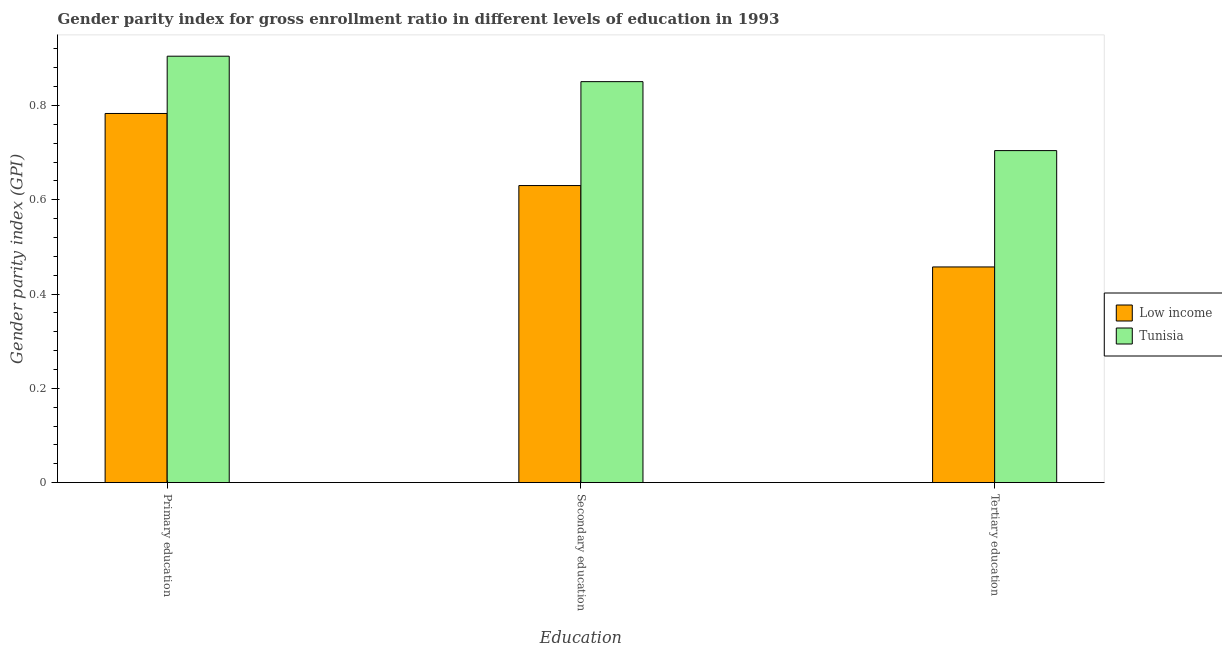How many different coloured bars are there?
Your response must be concise. 2. How many groups of bars are there?
Offer a terse response. 3. Are the number of bars per tick equal to the number of legend labels?
Provide a short and direct response. Yes. How many bars are there on the 3rd tick from the right?
Offer a terse response. 2. What is the label of the 2nd group of bars from the left?
Offer a terse response. Secondary education. What is the gender parity index in tertiary education in Low income?
Make the answer very short. 0.46. Across all countries, what is the maximum gender parity index in secondary education?
Provide a succinct answer. 0.85. Across all countries, what is the minimum gender parity index in primary education?
Your answer should be compact. 0.78. In which country was the gender parity index in secondary education maximum?
Offer a terse response. Tunisia. In which country was the gender parity index in secondary education minimum?
Provide a succinct answer. Low income. What is the total gender parity index in tertiary education in the graph?
Your answer should be compact. 1.16. What is the difference between the gender parity index in primary education in Low income and that in Tunisia?
Offer a very short reply. -0.12. What is the difference between the gender parity index in primary education in Low income and the gender parity index in tertiary education in Tunisia?
Your answer should be very brief. 0.08. What is the average gender parity index in primary education per country?
Your answer should be compact. 0.84. What is the difference between the gender parity index in secondary education and gender parity index in tertiary education in Low income?
Give a very brief answer. 0.17. What is the ratio of the gender parity index in tertiary education in Tunisia to that in Low income?
Your response must be concise. 1.54. Is the gender parity index in secondary education in Low income less than that in Tunisia?
Your response must be concise. Yes. Is the difference between the gender parity index in tertiary education in Tunisia and Low income greater than the difference between the gender parity index in secondary education in Tunisia and Low income?
Make the answer very short. Yes. What is the difference between the highest and the second highest gender parity index in tertiary education?
Offer a very short reply. 0.25. What is the difference between the highest and the lowest gender parity index in primary education?
Give a very brief answer. 0.12. In how many countries, is the gender parity index in tertiary education greater than the average gender parity index in tertiary education taken over all countries?
Your response must be concise. 1. What does the 2nd bar from the left in Secondary education represents?
Give a very brief answer. Tunisia. What does the 1st bar from the right in Tertiary education represents?
Your answer should be very brief. Tunisia. What is the difference between two consecutive major ticks on the Y-axis?
Ensure brevity in your answer.  0.2. Are the values on the major ticks of Y-axis written in scientific E-notation?
Ensure brevity in your answer.  No. What is the title of the graph?
Give a very brief answer. Gender parity index for gross enrollment ratio in different levels of education in 1993. What is the label or title of the X-axis?
Provide a short and direct response. Education. What is the label or title of the Y-axis?
Offer a terse response. Gender parity index (GPI). What is the Gender parity index (GPI) of Low income in Primary education?
Provide a short and direct response. 0.78. What is the Gender parity index (GPI) of Tunisia in Primary education?
Provide a short and direct response. 0.9. What is the Gender parity index (GPI) of Low income in Secondary education?
Your answer should be very brief. 0.63. What is the Gender parity index (GPI) of Tunisia in Secondary education?
Provide a short and direct response. 0.85. What is the Gender parity index (GPI) of Low income in Tertiary education?
Ensure brevity in your answer.  0.46. What is the Gender parity index (GPI) of Tunisia in Tertiary education?
Provide a succinct answer. 0.7. Across all Education, what is the maximum Gender parity index (GPI) of Low income?
Your answer should be very brief. 0.78. Across all Education, what is the maximum Gender parity index (GPI) of Tunisia?
Offer a very short reply. 0.9. Across all Education, what is the minimum Gender parity index (GPI) of Low income?
Your answer should be very brief. 0.46. Across all Education, what is the minimum Gender parity index (GPI) in Tunisia?
Keep it short and to the point. 0.7. What is the total Gender parity index (GPI) in Low income in the graph?
Your answer should be very brief. 1.87. What is the total Gender parity index (GPI) of Tunisia in the graph?
Provide a succinct answer. 2.46. What is the difference between the Gender parity index (GPI) of Low income in Primary education and that in Secondary education?
Your response must be concise. 0.15. What is the difference between the Gender parity index (GPI) in Tunisia in Primary education and that in Secondary education?
Your answer should be very brief. 0.05. What is the difference between the Gender parity index (GPI) of Low income in Primary education and that in Tertiary education?
Offer a terse response. 0.33. What is the difference between the Gender parity index (GPI) of Tunisia in Primary education and that in Tertiary education?
Give a very brief answer. 0.2. What is the difference between the Gender parity index (GPI) in Low income in Secondary education and that in Tertiary education?
Your response must be concise. 0.17. What is the difference between the Gender parity index (GPI) of Tunisia in Secondary education and that in Tertiary education?
Your response must be concise. 0.15. What is the difference between the Gender parity index (GPI) of Low income in Primary education and the Gender parity index (GPI) of Tunisia in Secondary education?
Offer a very short reply. -0.07. What is the difference between the Gender parity index (GPI) in Low income in Primary education and the Gender parity index (GPI) in Tunisia in Tertiary education?
Your answer should be very brief. 0.08. What is the difference between the Gender parity index (GPI) in Low income in Secondary education and the Gender parity index (GPI) in Tunisia in Tertiary education?
Provide a succinct answer. -0.07. What is the average Gender parity index (GPI) in Low income per Education?
Your response must be concise. 0.62. What is the average Gender parity index (GPI) in Tunisia per Education?
Offer a terse response. 0.82. What is the difference between the Gender parity index (GPI) of Low income and Gender parity index (GPI) of Tunisia in Primary education?
Your response must be concise. -0.12. What is the difference between the Gender parity index (GPI) of Low income and Gender parity index (GPI) of Tunisia in Secondary education?
Provide a short and direct response. -0.22. What is the difference between the Gender parity index (GPI) in Low income and Gender parity index (GPI) in Tunisia in Tertiary education?
Give a very brief answer. -0.25. What is the ratio of the Gender parity index (GPI) of Low income in Primary education to that in Secondary education?
Keep it short and to the point. 1.24. What is the ratio of the Gender parity index (GPI) in Tunisia in Primary education to that in Secondary education?
Give a very brief answer. 1.06. What is the ratio of the Gender parity index (GPI) of Low income in Primary education to that in Tertiary education?
Offer a very short reply. 1.71. What is the ratio of the Gender parity index (GPI) in Tunisia in Primary education to that in Tertiary education?
Your response must be concise. 1.28. What is the ratio of the Gender parity index (GPI) in Low income in Secondary education to that in Tertiary education?
Your answer should be very brief. 1.38. What is the ratio of the Gender parity index (GPI) in Tunisia in Secondary education to that in Tertiary education?
Ensure brevity in your answer.  1.21. What is the difference between the highest and the second highest Gender parity index (GPI) in Low income?
Provide a succinct answer. 0.15. What is the difference between the highest and the second highest Gender parity index (GPI) of Tunisia?
Your response must be concise. 0.05. What is the difference between the highest and the lowest Gender parity index (GPI) in Low income?
Your response must be concise. 0.33. What is the difference between the highest and the lowest Gender parity index (GPI) in Tunisia?
Keep it short and to the point. 0.2. 